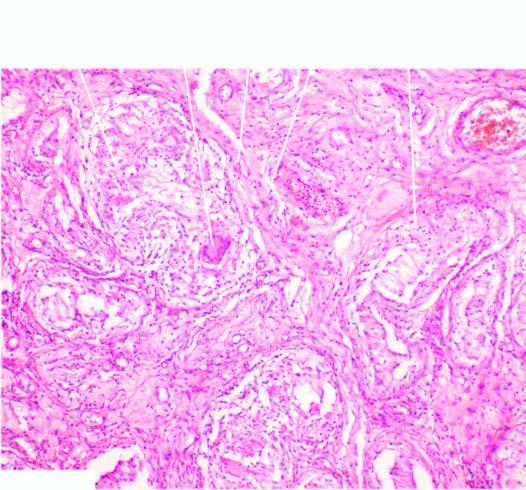does the interstitium contain several epithelioid cell granulomas with central areas of caseation necrosis?
Answer the question using a single word or phrase. Yes 